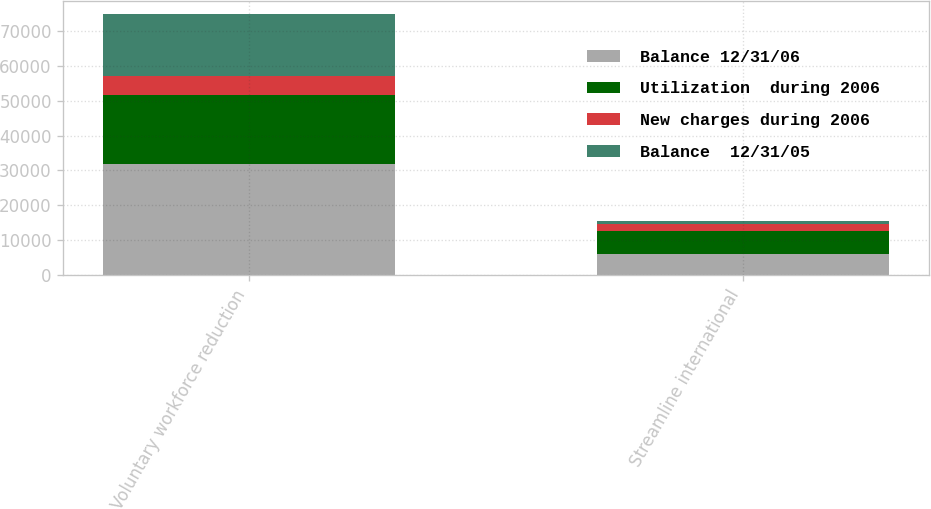Convert chart to OTSL. <chart><loc_0><loc_0><loc_500><loc_500><stacked_bar_chart><ecel><fcel>Voluntary workforce reduction<fcel>Streamline international<nl><fcel>Balance 12/31/06<fcel>31883<fcel>5888<nl><fcel>Utilization  during 2006<fcel>19727<fcel>6723<nl><fcel>New charges during 2006<fcel>5531<fcel>1896<nl><fcel>Balance  12/31/05<fcel>17687<fcel>1061<nl></chart> 